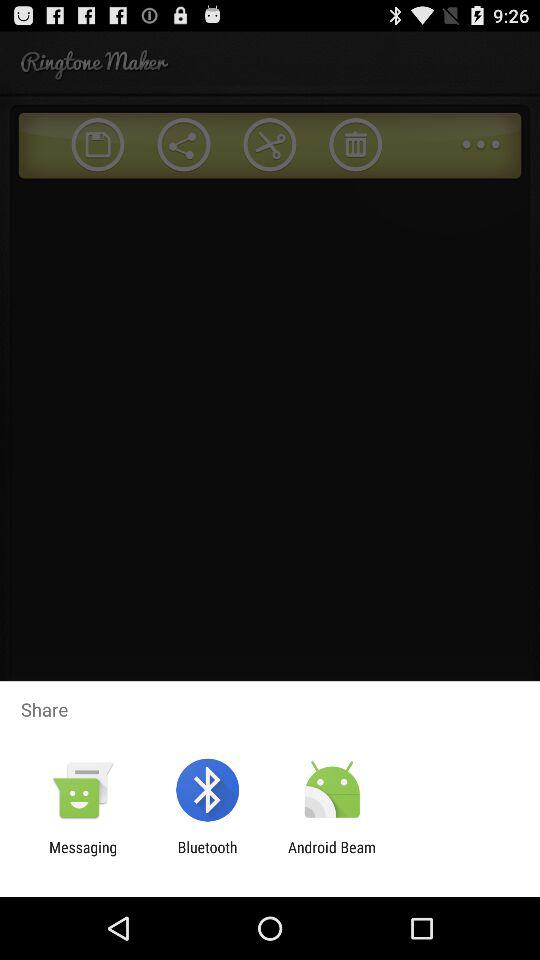Which application can be used to share? The applications "Messaging", "Bluetooth" and "Android Beam" can be used to share. 